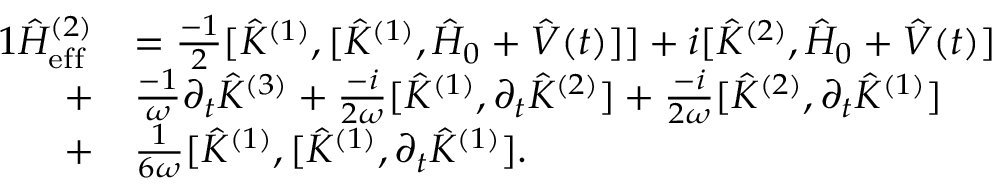Convert formula to latex. <formula><loc_0><loc_0><loc_500><loc_500>\begin{array} { r l } { { 1 } \hat { H } _ { e f f } ^ { ( 2 ) } } & { = \frac { - 1 } { 2 } [ \hat { K } ^ { ( 1 ) } , [ \hat { K } ^ { ( 1 ) } , \hat { H } _ { 0 } + \hat { V } ( t ) ] ] + i [ \hat { K } ^ { ( 2 ) } , \hat { H } _ { 0 } + \hat { V } ( t ) ] } \\ { + } & { \frac { - 1 } { \omega } \partial _ { t } \hat { K } ^ { ( 3 ) } + \frac { - i } { 2 \omega } [ \hat { K } ^ { ( 1 ) } , \partial _ { t } \hat { K } ^ { ( 2 ) } ] + \frac { - i } { 2 \omega } [ \hat { K } ^ { ( 2 ) } , \partial _ { t } \hat { K } ^ { ( 1 ) } ] } \\ { + } & { \frac { 1 } { 6 \omega } [ \hat { K } ^ { ( 1 ) } , [ \hat { K } ^ { ( 1 ) } , \partial _ { t } \hat { K } ^ { ( 1 ) } ] . } \end{array}</formula> 